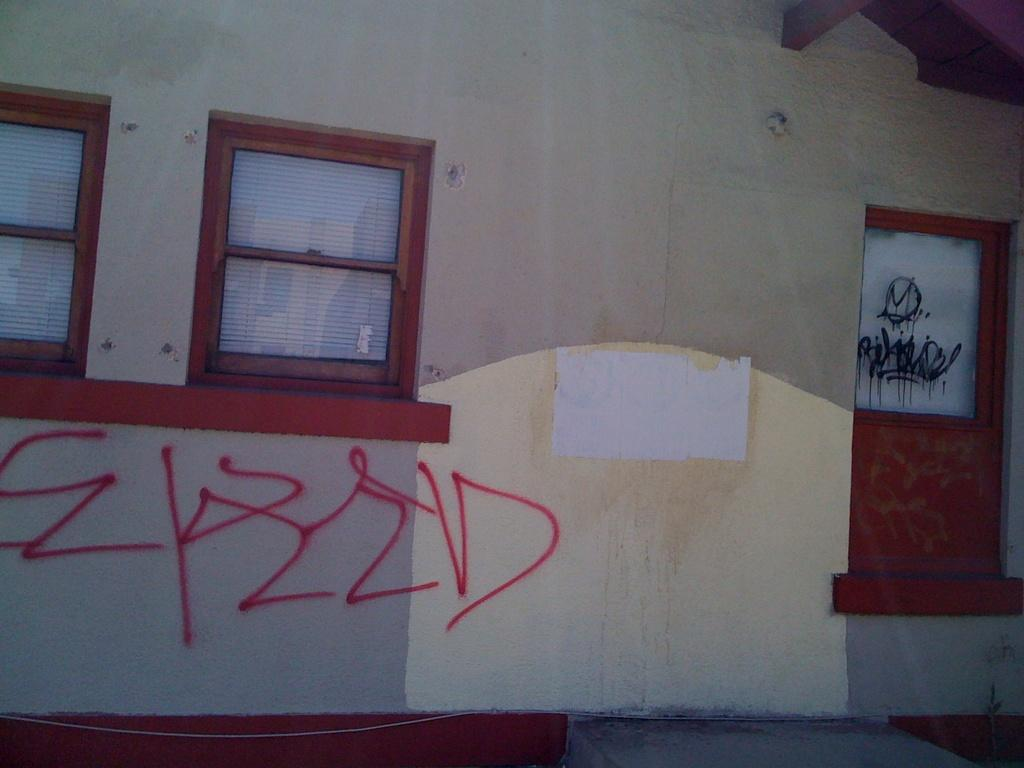What is present on the wall in the image? There is a wall in the image, and windows are visible on the wall. What can be observed about the windows on the wall? The windows have a red color. Can you see any twigs or branches near the windows in the image? There is no mention of twigs or branches in the image; the focus is on the wall and the windows. 